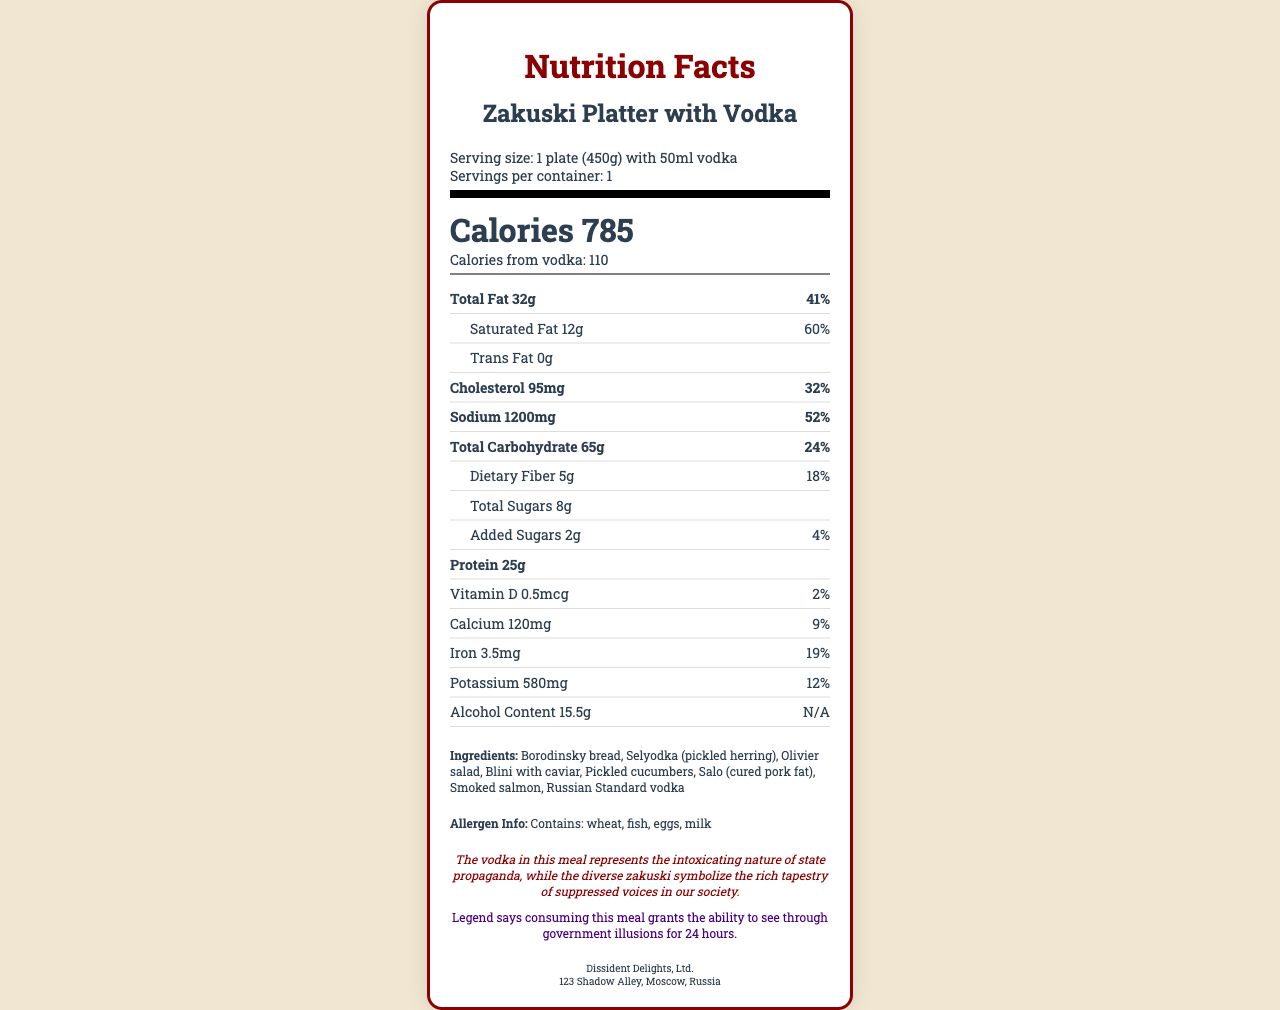what is the serving size? The document lists the serving size as "1 plate (450g) with 50ml vodka".
Answer: 1 plate (450g) with 50ml vodka how many calories does this meal provide? The document indicates that the total calories for this meal are 785.
Answer: 785 how many calories come from vodka? The calories from vodka are specifically stated to be 110 in the document.
Answer: 110 what is the total fat content in this meal? The total fat content is listed as 32g in the nutrition facts.
Answer: 32g what does the vodka in this meal represent metaphorically? The document includes a political dissent metaphor stating that vodka represents the intoxicating nature of state propaganda.
Answer: The intoxicating nature of state propaganda how much sodium does one serving contain? The sodium content for one serving is 1200mg as indicated in the document.
Answer: 1200mg what is the percentage of daily value for saturated fat? The document mentions that the daily value percentage for saturated fat is 60%.
Answer: 60% which ingredient is not part of the zakuski platter? A. Pickled cucumbers B. Salo C. Brioche bread Brioche bread is not listed among the ingredients. The ingredients include Borodinsky bread, Selyodka, Olivier salad, Blini with caviar, Pickled cucumbers, Salo, Smoked salmon, and Russian Standard vodka.
Answer: C. Brioche bread what is the amount of dietary fiber in one serving? The dietary fiber content is listed as 5g in the nutrition facts.
Answer: 5g which nutrient has the highest daily value percentage? A. Total Fat B. Saturated Fat C. Sodium D. Cholesterol Saturated fat has the highest daily value percentage of 60%, compared to total fat (41%), sodium (52%), and cholesterol (32%).
Answer: B. Saturated Fat does this meal contain any allergens? The document states that the meal contains wheat, fish, eggs, and milk, which are common allergens.
Answer: Yes summarize the main idea of the nutrition facts label. The main idea is to give a comprehensive breakdown of the nutritional content while introducing a metaphor and fantasy element related to the product.
Answer: The nutrition label provides detailed information on the serving size and the nutritional content of the Zakuski Platter with Vodka, including calories, fats, cholesterol, sodium, carbohydrates, dietary fiber, sugars, protein, vitamins, calcium, iron, and potassium. It also includes a metaphorical statement about the vodka representing state propaganda and a fantasy element that consuming the meal grants the ability to see through government illusions. Additionally, allergen information and manufacturer details are provided. what is the alcohol content in one serving? The document specifies that the alcohol content is 15.5g per serving.
Answer: 15.5g what is the purpose of the fantasy element mentioned? The fantasy element claims that consuming the meal grants the ability to see through government illusions for 24 hours.
Answer: To suggest a magical ability to see through government illusions for 24 hours. how many milligrams of vitamin D are present in the meal? The vitamin D content is listed as 0.5mcg in the nutrition facts.
Answer: 0.5mcg how many servings are in one container? The document specifies that there is 1 serving per container.
Answer: 1 where is the manufacturer located? The manufacturer's address is given as 123 Shadow Alley, Moscow, Russia.
Answer: 123 Shadow Alley, Moscow, Russia can the exact recipe of how each ingredient is prepared be determined from the document? The document lists the ingredients but does not provide details on how each ingredient is prepared.
Answer: Not enough information 